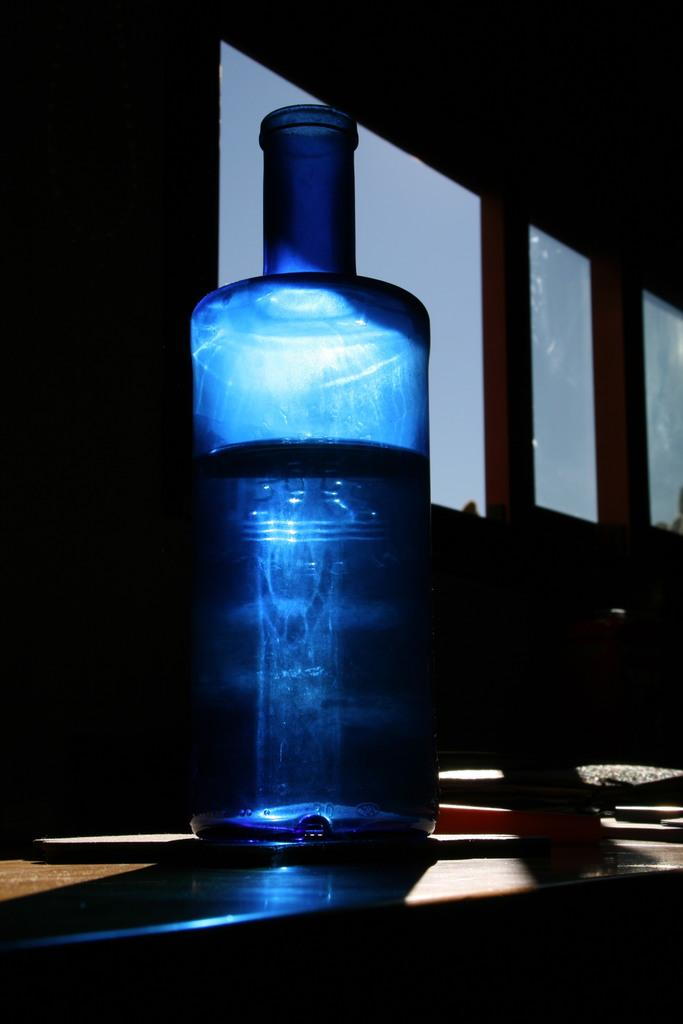What object is present in the image? There is a bottle in the image. Where is the bottle located? The bottle is placed on a table. How many bikes are parked next to the bottle in the image? There are no bikes present in the image; it only features a bottle placed on a table. 